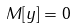Convert formula to latex. <formula><loc_0><loc_0><loc_500><loc_500>M [ y ] = 0</formula> 